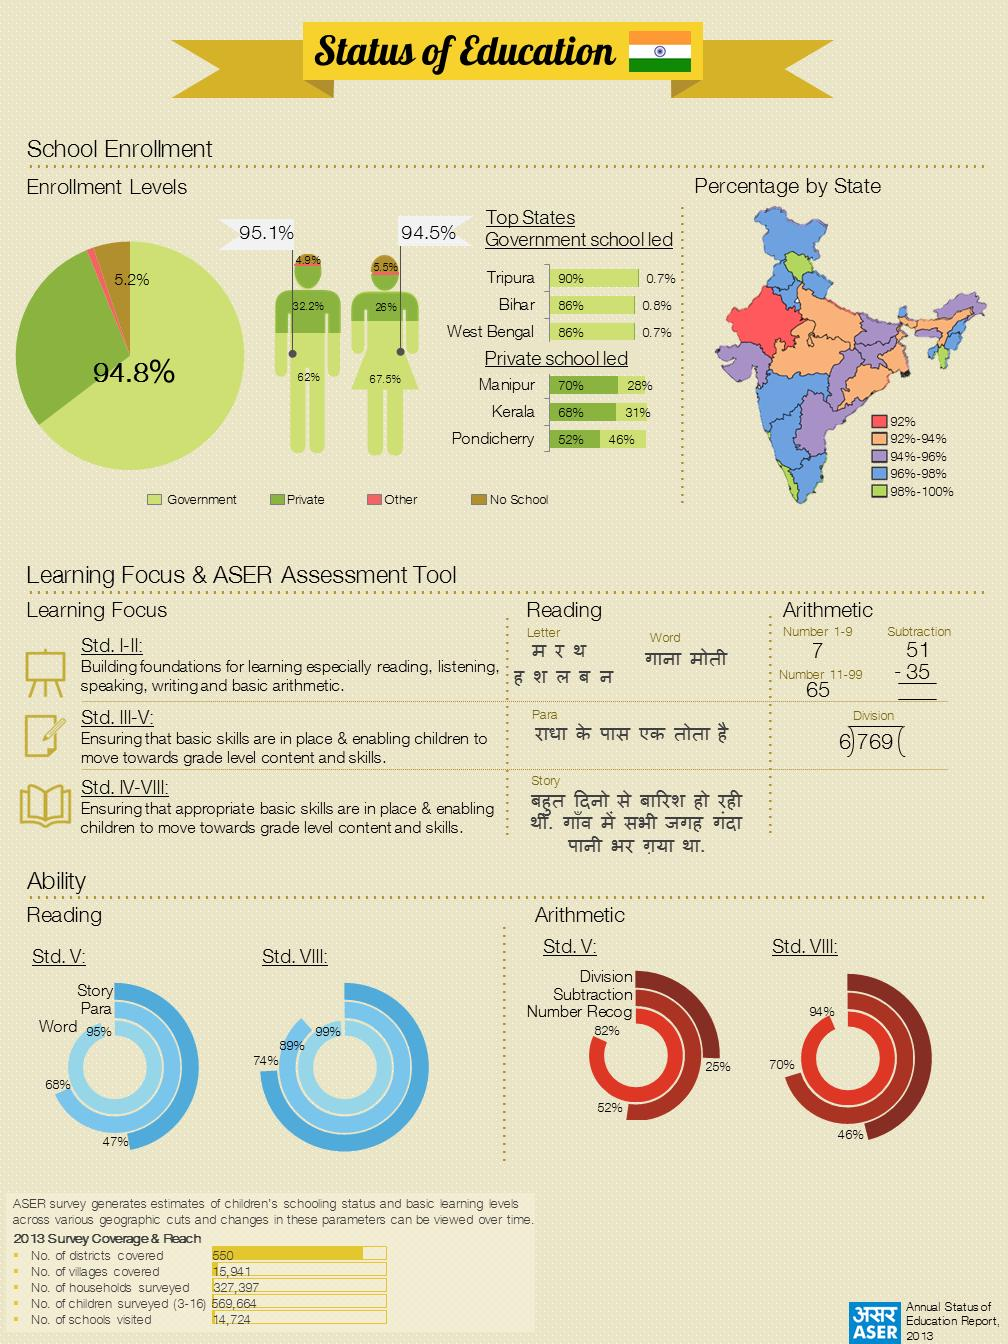Highlight a few significant elements in this photo. Seven states have enrollment percentages ranging from 94% to 96%. The government has the highest share of private funding compared to other entities. Three states have enrollment percentages between 98% and 100%. The division ability of Std VIII students is higher than that of Std V students. The total number of districts and villages taken together is 16,491. 